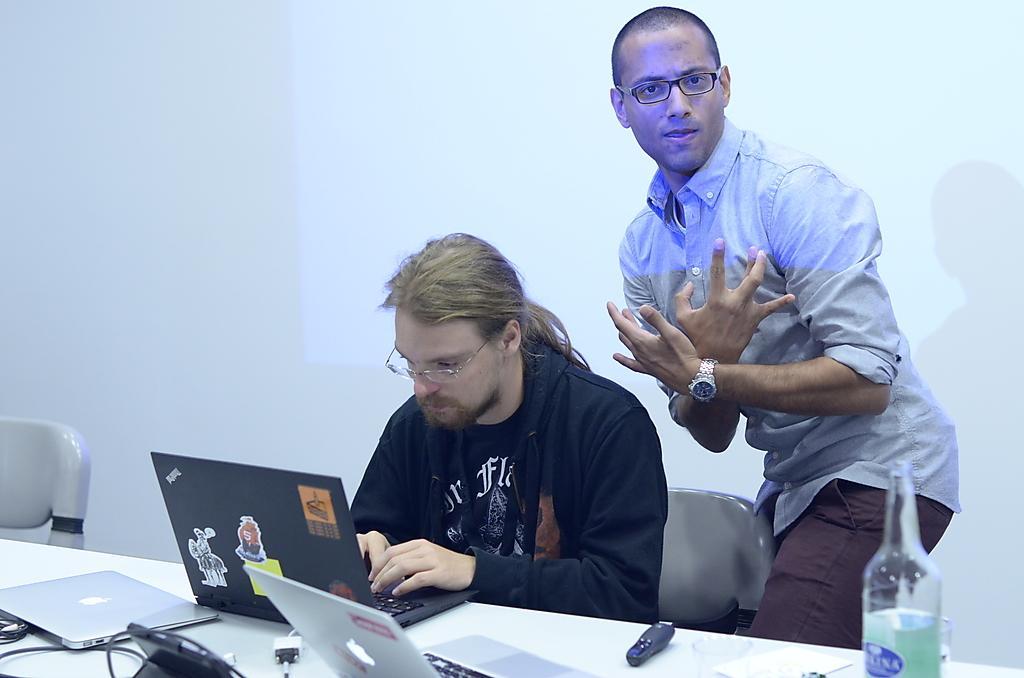Please provide a concise description of this image. In this picture we can see two men wore spectacles and a man sitting on a chair. In front of them we can see the table with laptops, cables, bottle and some objects on it. In the background we can see the wall. 